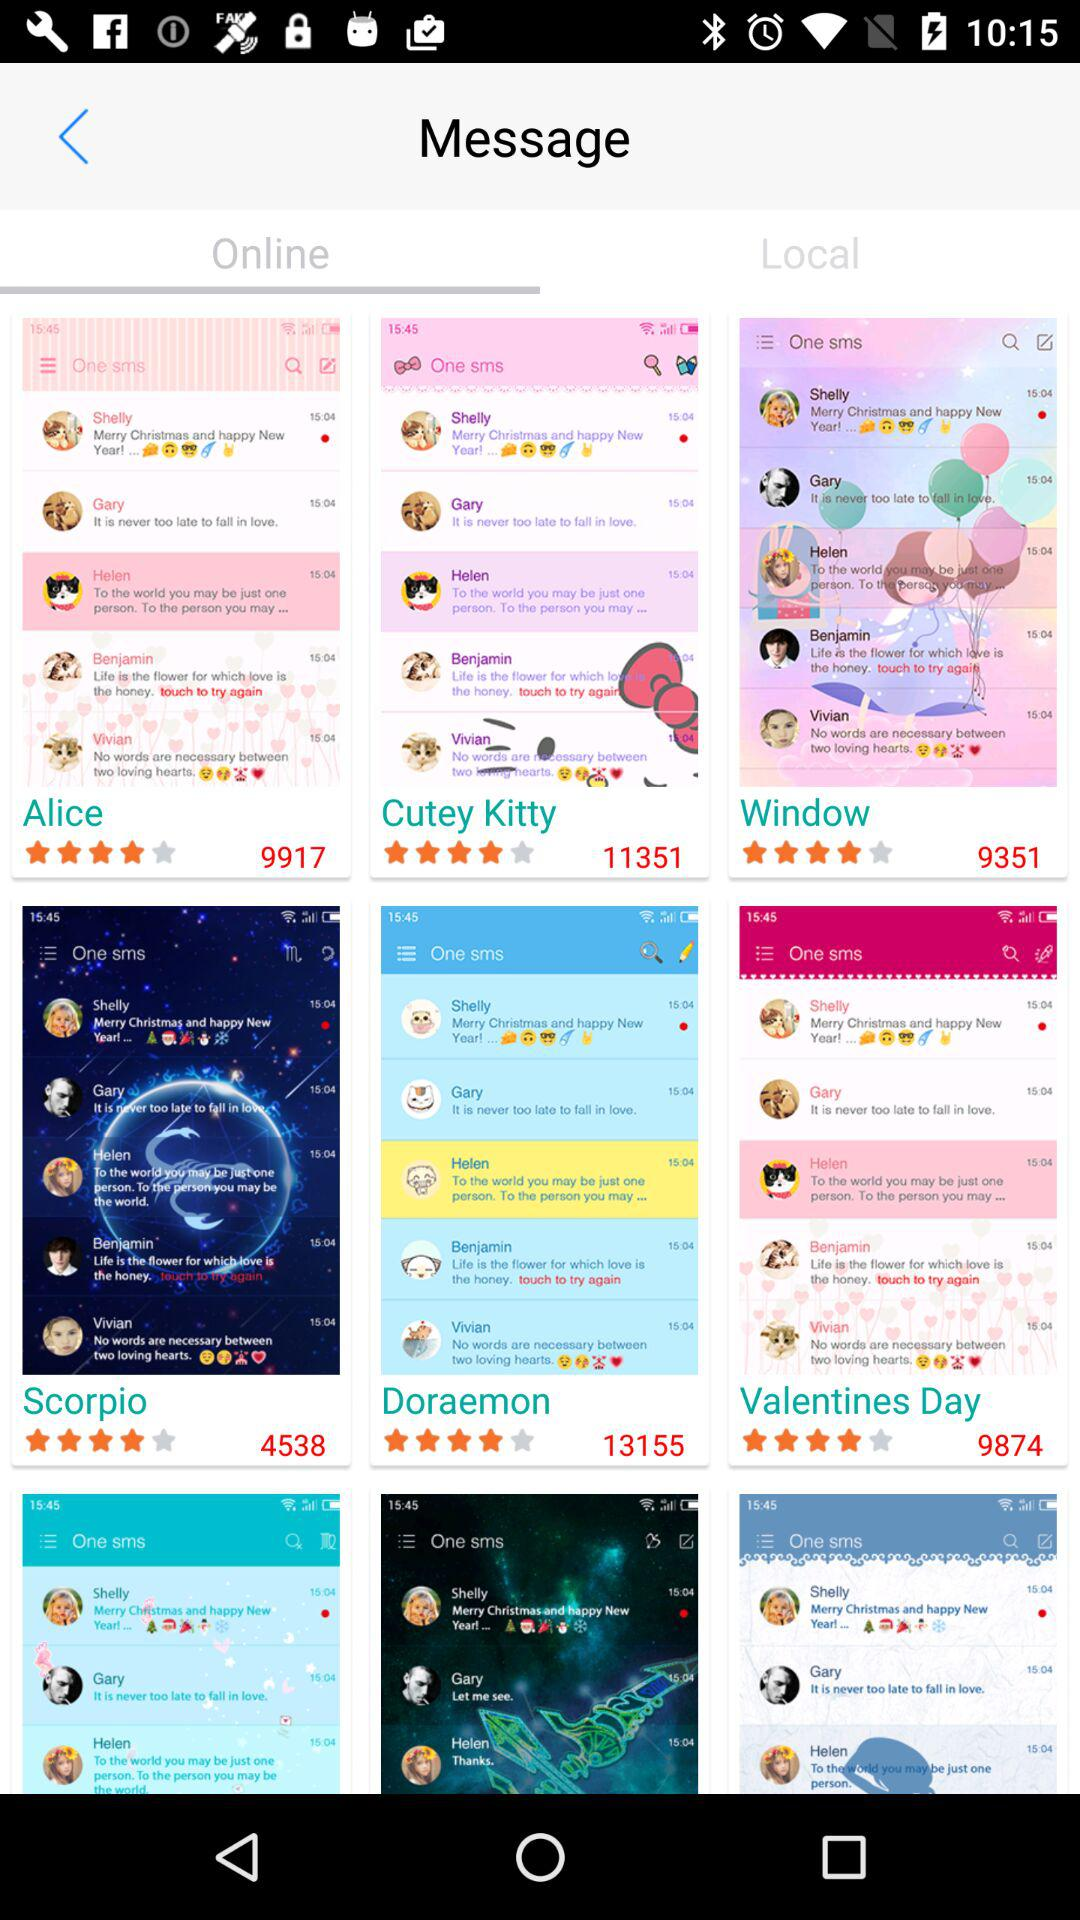How many users have rated "Alice"? "Alice" has been rated by 9917 people. 